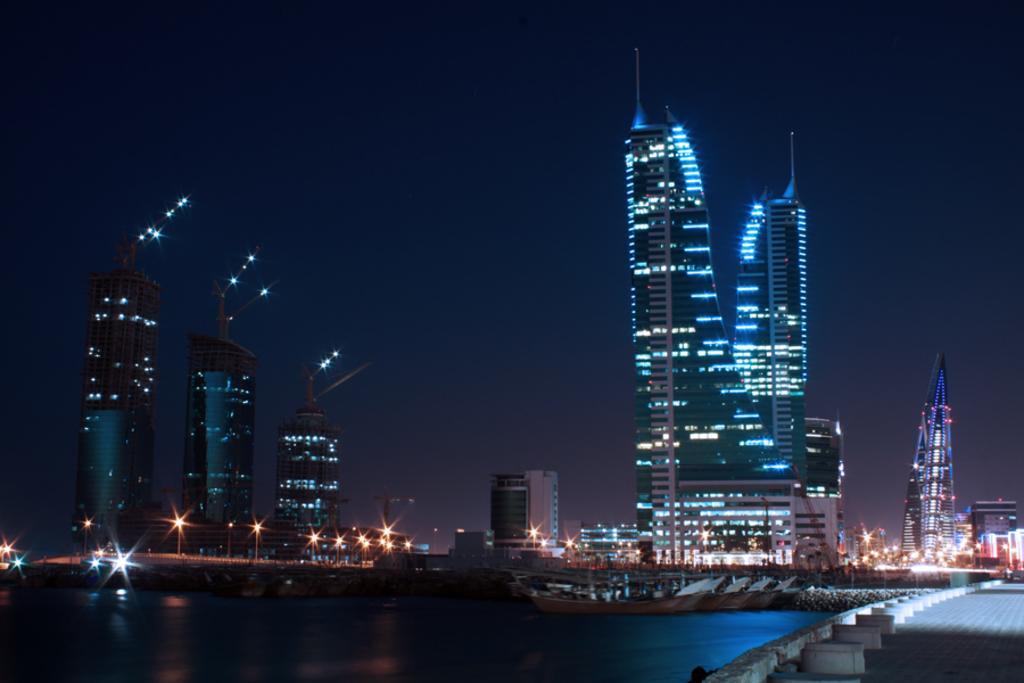How would you summarize this image in a sentence or two? In this picture we can see some buildings here, at the left bottom we can see water, there are some lights in the background, we can see the sky at the top of the picture. 